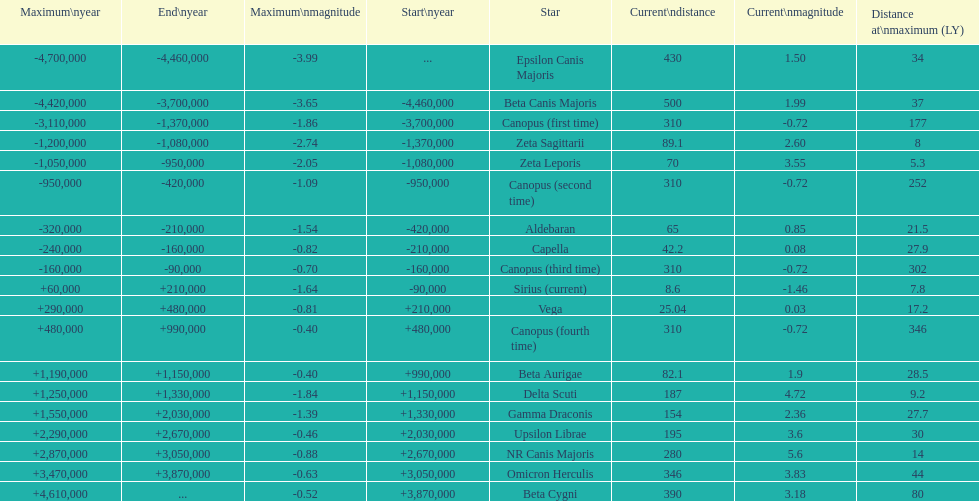Which star has the highest distance at maximum? Canopus (fourth time). 